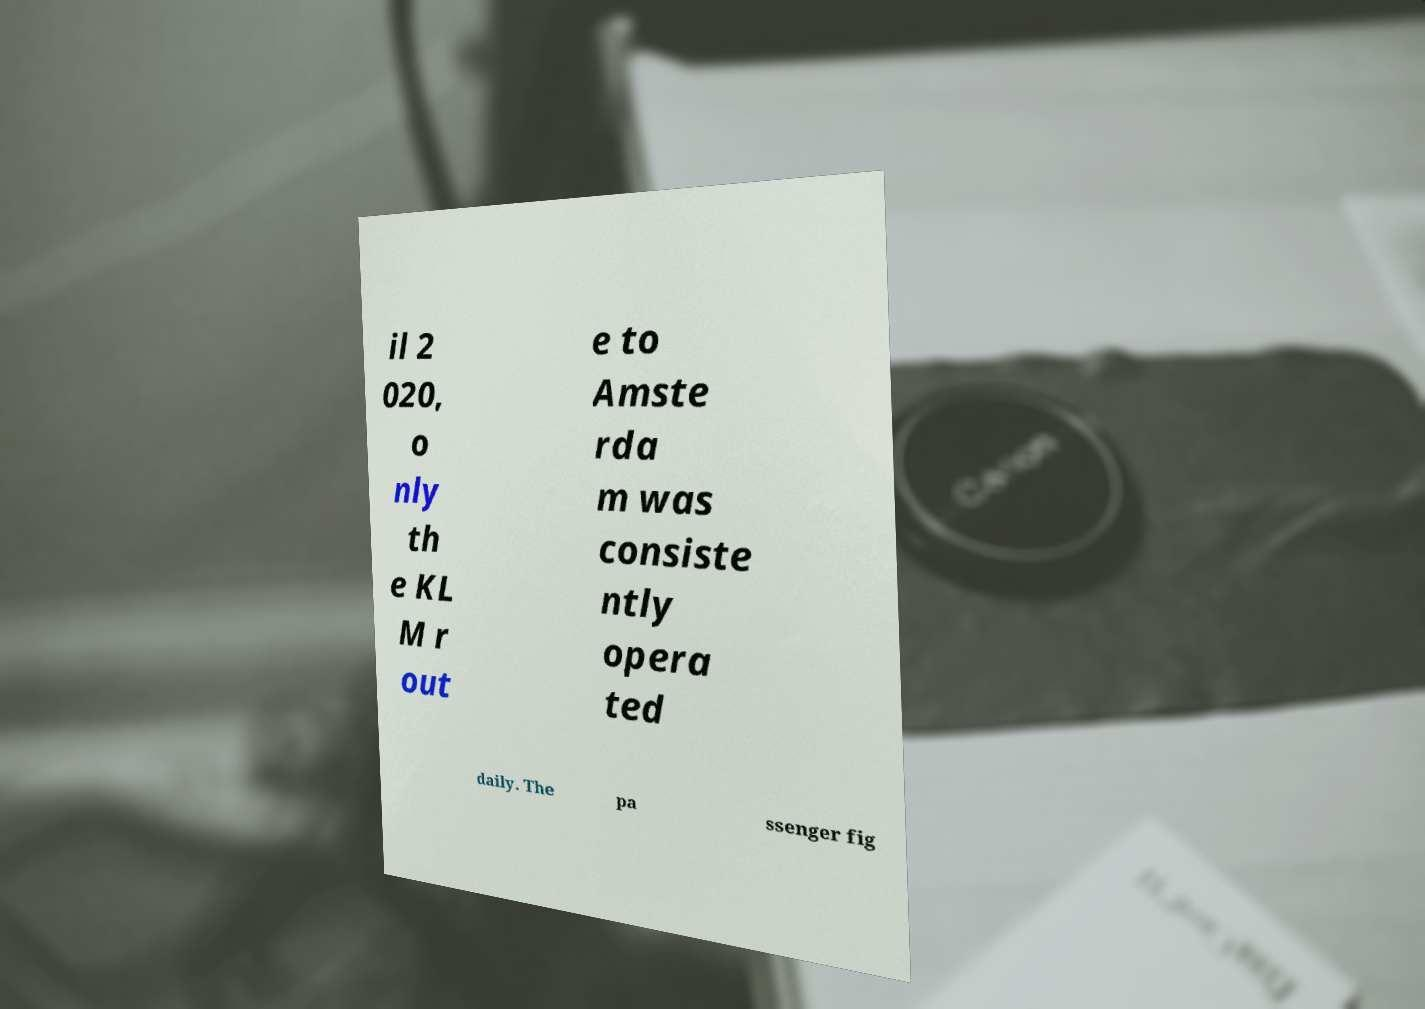Please read and relay the text visible in this image. What does it say? il 2 020, o nly th e KL M r out e to Amste rda m was consiste ntly opera ted daily. The pa ssenger fig 